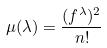<formula> <loc_0><loc_0><loc_500><loc_500>\mu ( \lambda ) = \frac { ( f ^ { \lambda } ) ^ { 2 } } { n ! }</formula> 